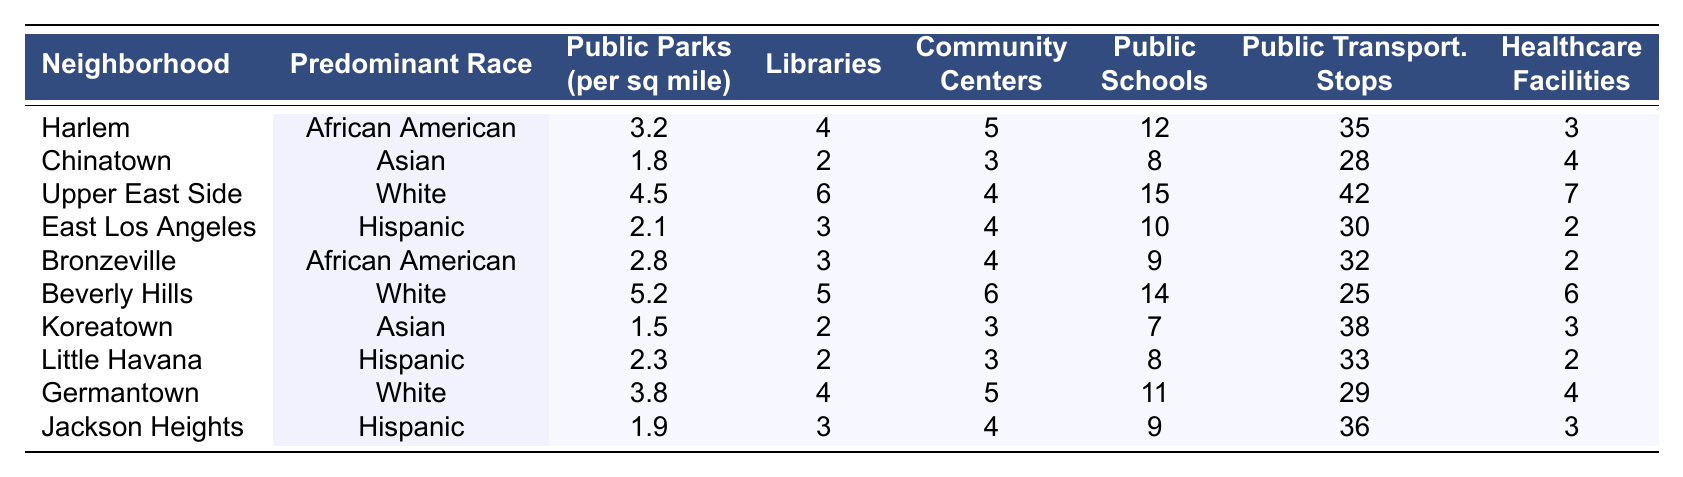What is the predominant race in Harlem? Looking at the table, Harlem has "African American" listed as its predominant race in the corresponding row.
Answer: African American How many public parks are there per square mile in the Upper East Side? The Upper East Side's row indicates there are 4.5 public parks per square mile.
Answer: 4.5 Which neighborhood has the highest number of public transportation stops? By examining the table, the Upper East Side has the highest number of public transportation stops at 42.
Answer: Upper East Side What is the average number of healthcare facilities across all neighborhoods? Summing the number of healthcare facilities: (3 + 4 + 7 + 2 + 2 + 6 + 3 + 2 + 4 + 3) = 36, and dividing by 10 neighborhoods gives an average of 3.6.
Answer: 3.6 Is it true that Little Havana has more libraries than East Los Angeles? Little Havana has 2 libraries and East Los Angeles has 3, so it is not true that Little Havana has more libraries.
Answer: No What is the difference in the number of public schools between the Upper East Side and Bronzeville? The Upper East Side has 15 public schools, while Bronzeville has 9 public schools. The difference is 15 - 9 = 6.
Answer: 6 Which neighborhood has the least number of community centers? By scanning the table, Koreatown and Chinatown both have the least number of community centers, with 3 each.
Answer: Koreatown and Chinatown What percentage of public parks per square mile does Beverly Hills have compared to Harlem? Beverly Hills has 5.2 parks and Harlem has 3.2 parks. The percentage is (5.2 - 3.2) / 3.2 * 100 = 62.5%.
Answer: 62.5% Do Hispanic neighborhoods tend to have fewer public parks per square mile than African American neighborhoods? Comparing the Hispanic neighborhoods: East Los Angeles (2.1) and Jackson Heights (1.9) with African American neighborhoods: Harlem (3.2) and Bronzeville (2.8), the Hispanic ones have lower public parks on average.
Answer: Yes If we sum the number of libraries for all neighborhoods, what is the total? Summing the libraries: (4 + 2 + 6 + 3 + 3 + 5 + 2 + 2 + 4 + 3) = 34 libraries total.
Answer: 34 